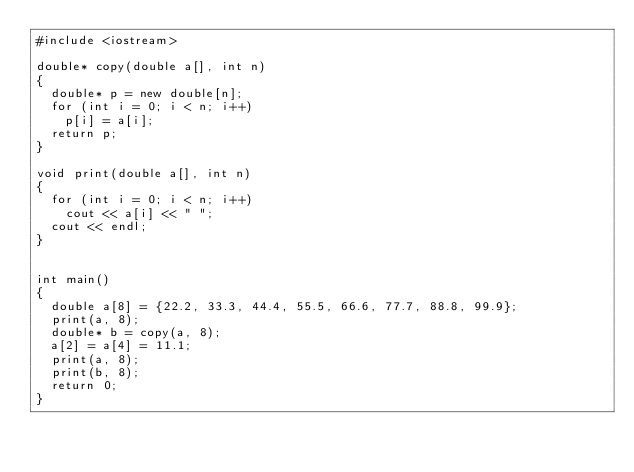Convert code to text. <code><loc_0><loc_0><loc_500><loc_500><_C++_>#include <iostream>

double* copy(double a[], int n)
{
  double* p = new double[n];
  for (int i = 0; i < n; i++)
    p[i] = a[i];
  return p;
}

void print(double a[], int n)
{
  for (int i = 0; i < n; i++)
    cout << a[i] << " ";
  cout << endl;
}


int main()
{
  double a[8] = {22.2, 33.3, 44.4, 55.5, 66.6, 77.7, 88.8, 99.9};
  print(a, 8);
  double* b = copy(a, 8);
  a[2] = a[4] = 11.1;
  print(a, 8);
  print(b, 8);
  return 0;
}
</code> 